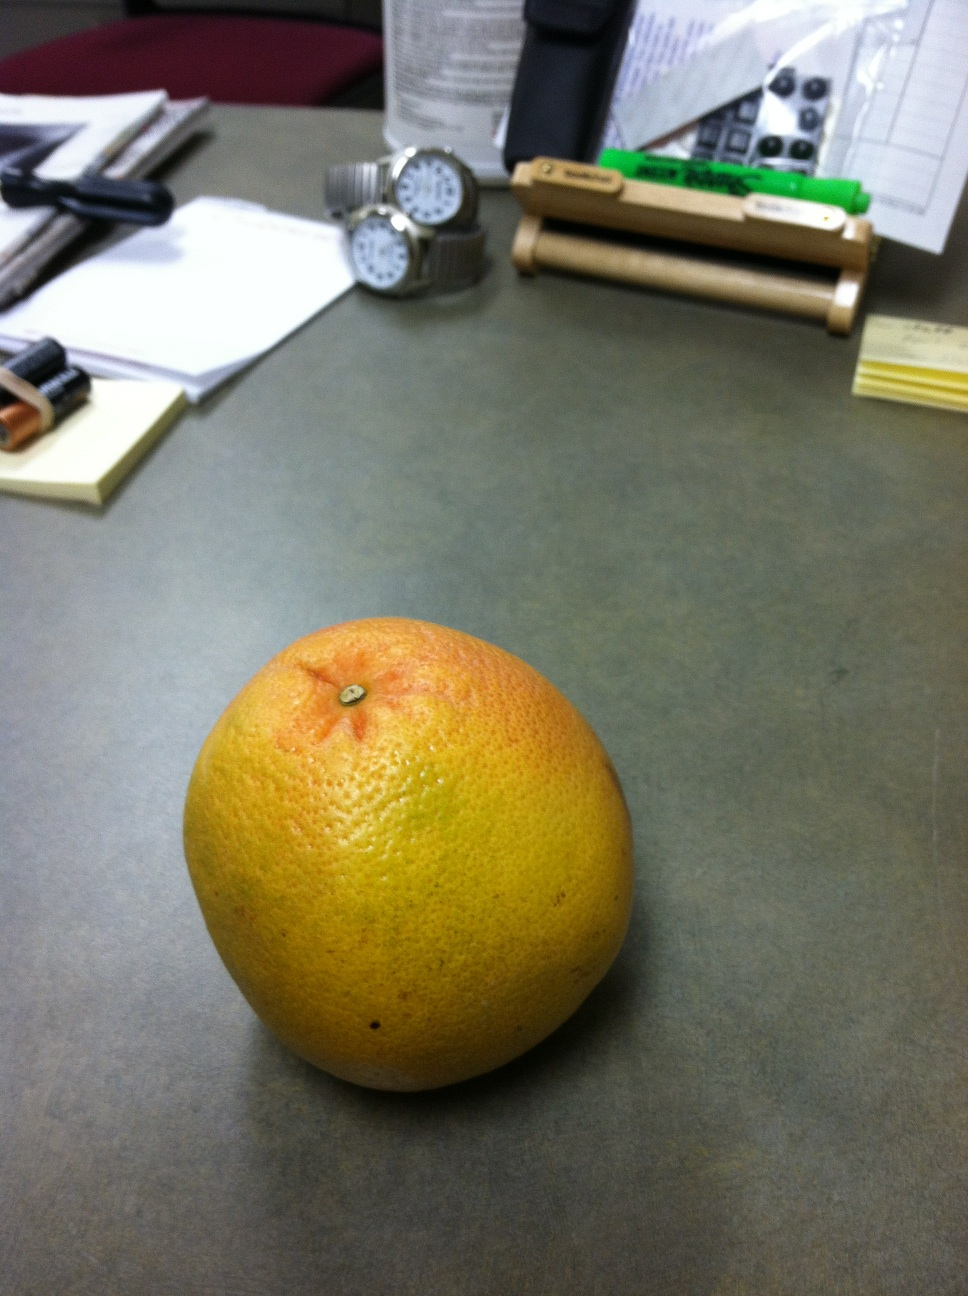What color is this? The color of the fruit is a vibrant blend of orange and yellow hues, with a hint of red undertones. It appears to be a grapefruit, laying on what seems to be an office desk with various items such as watches, batteries, and papers around it. 